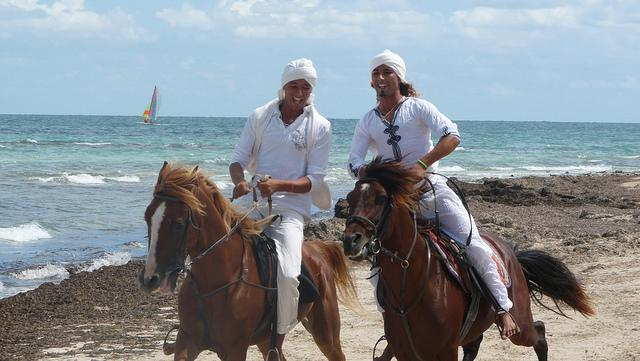Why are they so close together? friends 